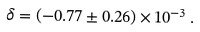<formula> <loc_0><loc_0><loc_500><loc_500>\delta = ( - 0 . 7 7 \pm 0 . 2 6 ) \times 1 0 ^ { - 3 } \, .</formula> 